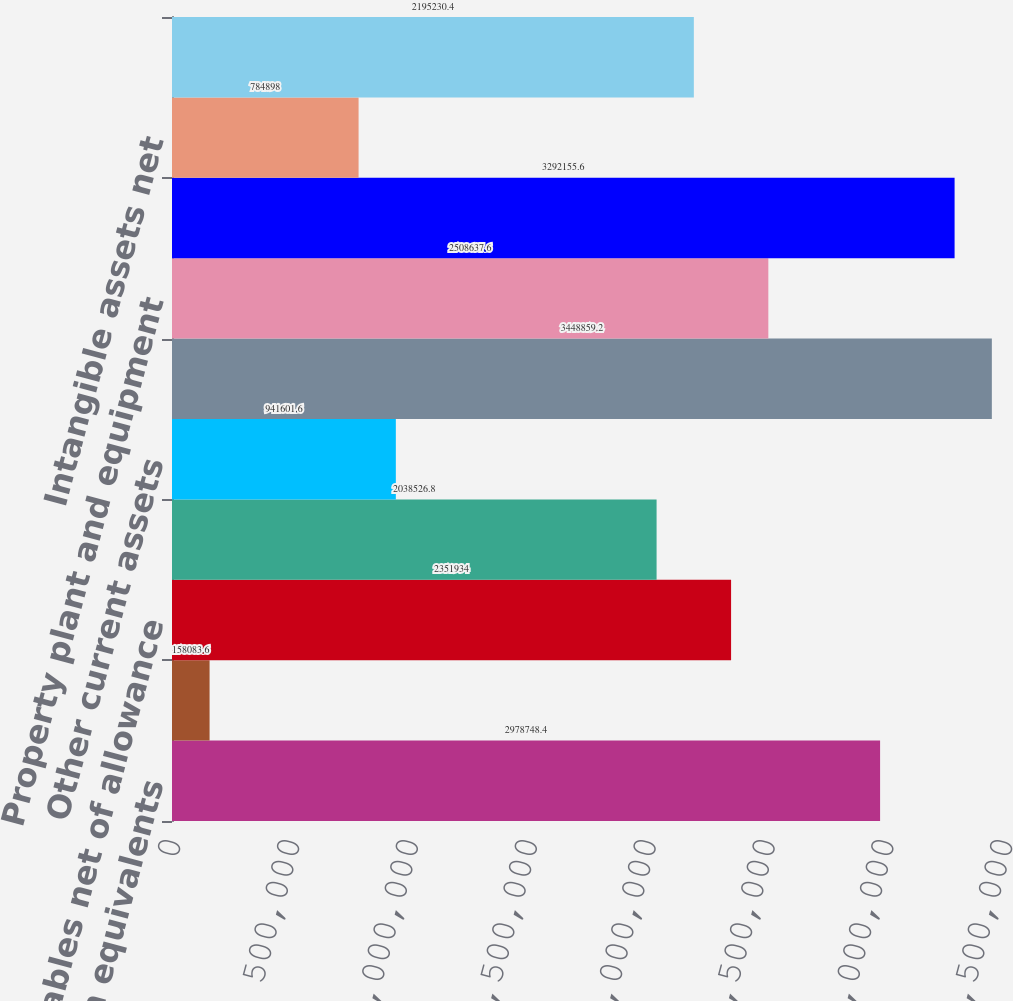<chart> <loc_0><loc_0><loc_500><loc_500><bar_chart><fcel>Cash and cash equivalents<fcel>Restricted cash<fcel>Receivables net of allowance<fcel>Inventories<fcel>Other current assets<fcel>Total current assets<fcel>Property plant and equipment<fcel>Goodwill<fcel>Intangible assets net<fcel>Deferred tax assets<nl><fcel>2.97875e+06<fcel>158084<fcel>2.35193e+06<fcel>2.03853e+06<fcel>941602<fcel>3.44886e+06<fcel>2.50864e+06<fcel>3.29216e+06<fcel>784898<fcel>2.19523e+06<nl></chart> 